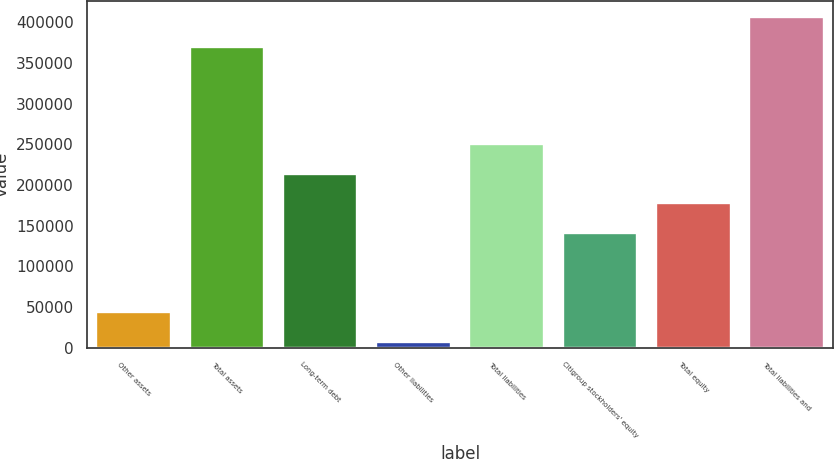Convert chart. <chart><loc_0><loc_0><loc_500><loc_500><bar_chart><fcel>Other assets<fcel>Total assets<fcel>Long-term debt<fcel>Other liabilities<fcel>Total liabilities<fcel>Citigroup stockholders' equity<fcel>Total equity<fcel>Total liabilities and<nl><fcel>43619.8<fcel>370075<fcel>214176<fcel>7347<fcel>250448<fcel>141630<fcel>177903<fcel>406348<nl></chart> 